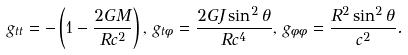<formula> <loc_0><loc_0><loc_500><loc_500>g _ { t t } = - \left ( 1 - \frac { 2 G M } { R c ^ { 2 } } \right ) , \, g _ { t \phi } = \frac { 2 G J \sin ^ { 2 } { \theta } } { R c ^ { 4 } } , \, g _ { \phi \phi } = \frac { R ^ { 2 } \sin ^ { 2 } { \theta } } { c ^ { 2 } } .</formula> 